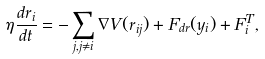<formula> <loc_0><loc_0><loc_500><loc_500>\eta \frac { d r _ { i } } { d t } = - \sum _ { j , j \neq i } { \nabla V } ( r _ { i j } ) + F _ { d r } ( y _ { i } ) + F _ { i } ^ { T } ,</formula> 